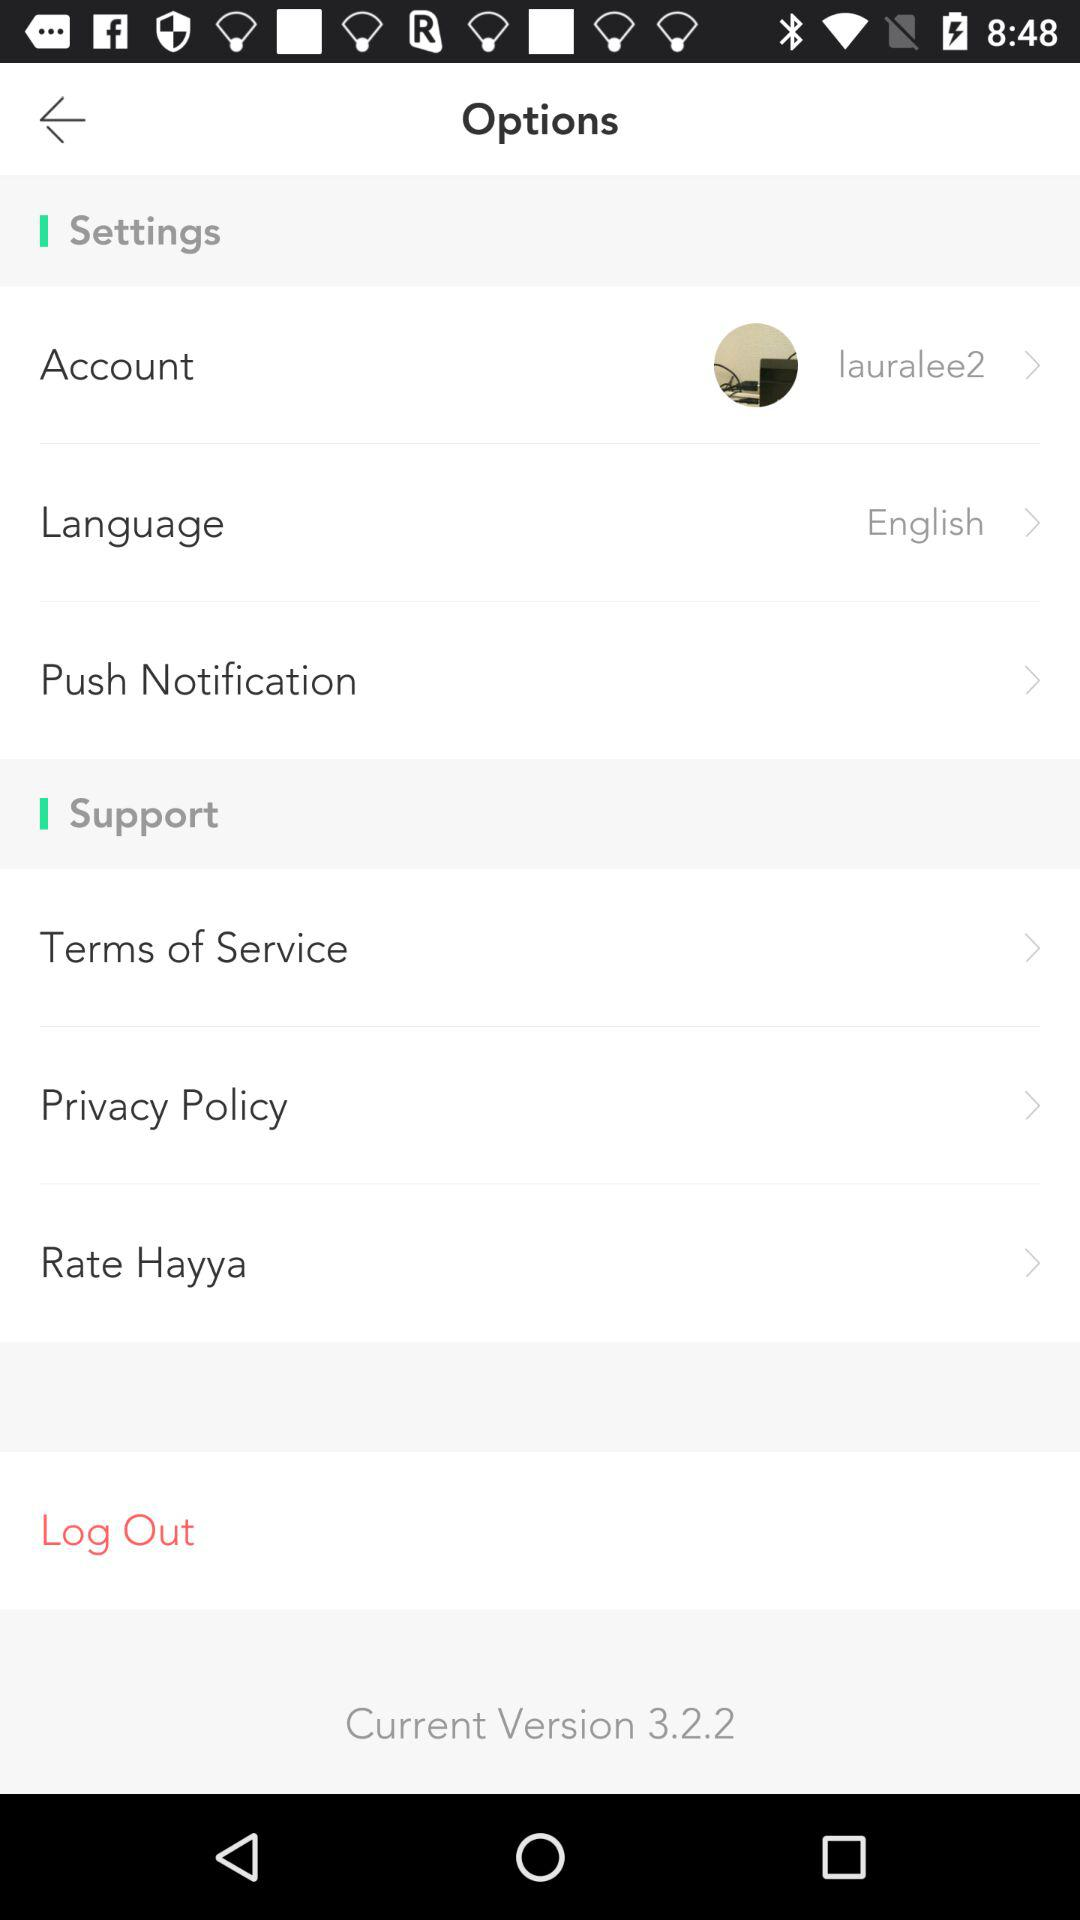What is the username? The username is "lauralee2". 